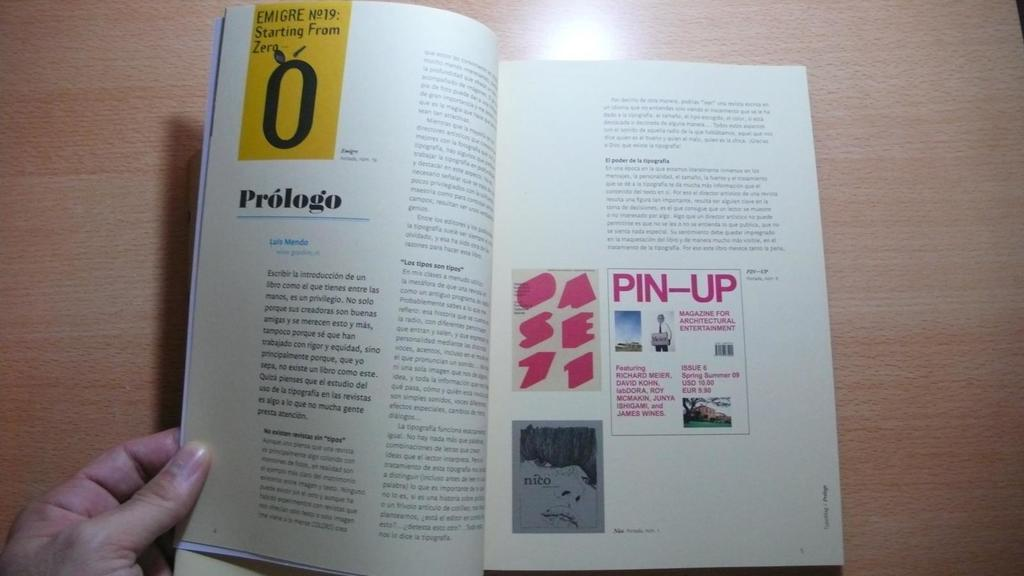<image>
Share a concise interpretation of the image provided. A hand holds a book open to a spread entitled Prologo. 